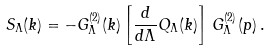<formula> <loc_0><loc_0><loc_500><loc_500>S _ { \Lambda } ( k ) = - G ^ { ( 2 ) } _ { \Lambda } ( k ) \left [ \frac { d } { d \Lambda } Q _ { \Lambda } ( k ) \right ] \, G ^ { ( 2 ) } _ { \Lambda } ( p ) \, .</formula> 